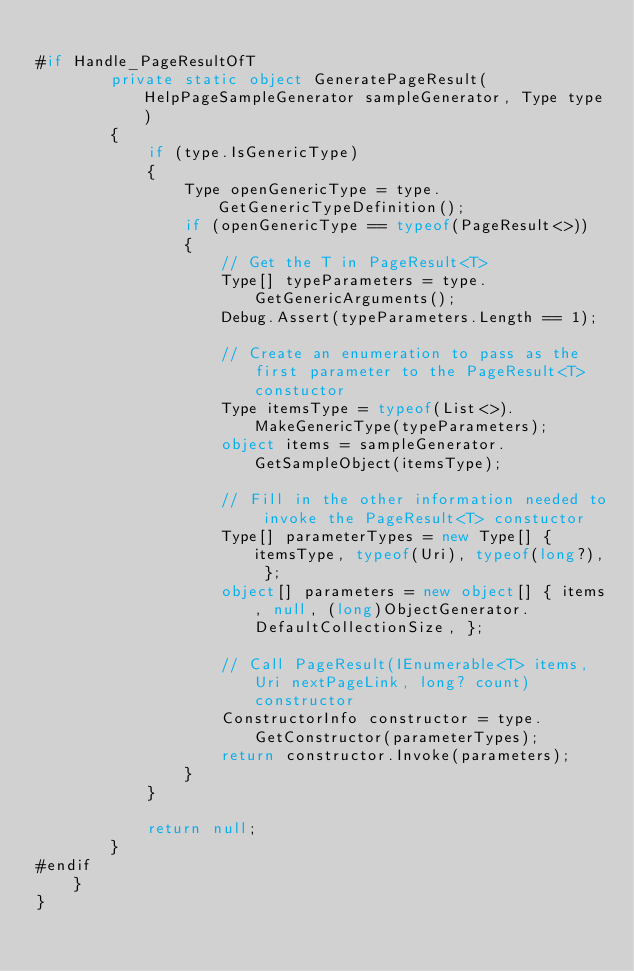<code> <loc_0><loc_0><loc_500><loc_500><_C#_>
#if Handle_PageResultOfT
        private static object GeneratePageResult(HelpPageSampleGenerator sampleGenerator, Type type)
        {
            if (type.IsGenericType)
            {
                Type openGenericType = type.GetGenericTypeDefinition();
                if (openGenericType == typeof(PageResult<>))
                {
                    // Get the T in PageResult<T>
                    Type[] typeParameters = type.GetGenericArguments();
                    Debug.Assert(typeParameters.Length == 1);

                    // Create an enumeration to pass as the first parameter to the PageResult<T> constuctor
                    Type itemsType = typeof(List<>).MakeGenericType(typeParameters);
                    object items = sampleGenerator.GetSampleObject(itemsType);

                    // Fill in the other information needed to invoke the PageResult<T> constuctor
                    Type[] parameterTypes = new Type[] { itemsType, typeof(Uri), typeof(long?), };
                    object[] parameters = new object[] { items, null, (long)ObjectGenerator.DefaultCollectionSize, };

                    // Call PageResult(IEnumerable<T> items, Uri nextPageLink, long? count) constructor
                    ConstructorInfo constructor = type.GetConstructor(parameterTypes);
                    return constructor.Invoke(parameters);
                }
            }

            return null;
        }
#endif
    }
}</code> 